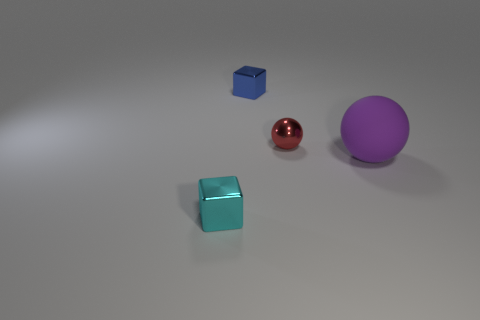How big is the metal object that is in front of the blue metal cube and to the right of the tiny cyan object?
Your answer should be compact. Small. What is the color of the shiny sphere that is the same size as the blue shiny object?
Provide a short and direct response. Red. What number of other things are the same color as the big matte thing?
Your response must be concise. 0. Are there more tiny metal blocks in front of the small blue thing than tiny cyan rubber cylinders?
Give a very brief answer. Yes. Are the tiny blue block and the red thing made of the same material?
Provide a short and direct response. Yes. How many things are metal blocks in front of the small shiny ball or tiny blue matte balls?
Make the answer very short. 1. How many other objects are the same size as the red ball?
Make the answer very short. 2. Are there an equal number of small red metal spheres right of the tiny red shiny sphere and tiny metal balls that are to the left of the tiny cyan metallic thing?
Make the answer very short. Yes. What is the color of the tiny thing that is the same shape as the big purple object?
Keep it short and to the point. Red. There is a purple thing that is the same shape as the red thing; what is its size?
Provide a short and direct response. Large. 